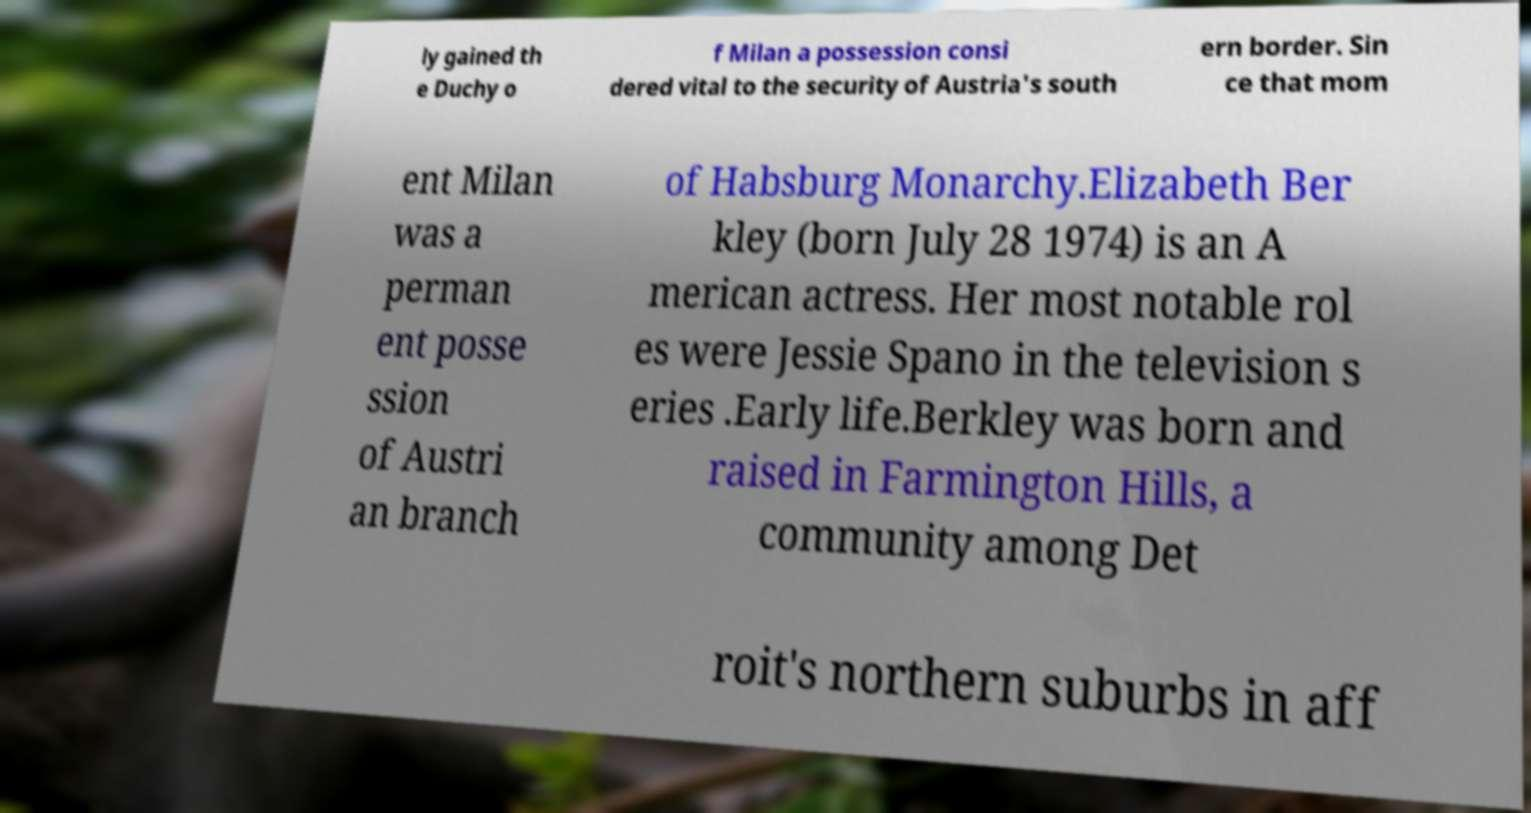Please identify and transcribe the text found in this image. ly gained th e Duchy o f Milan a possession consi dered vital to the security of Austria's south ern border. Sin ce that mom ent Milan was a perman ent posse ssion of Austri an branch of Habsburg Monarchy.Elizabeth Ber kley (born July 28 1974) is an A merican actress. Her most notable rol es were Jessie Spano in the television s eries .Early life.Berkley was born and raised in Farmington Hills, a community among Det roit's northern suburbs in aff 